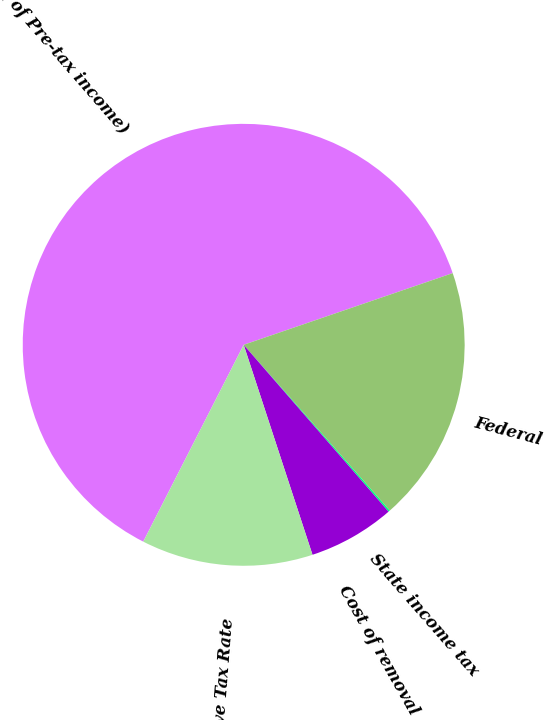Convert chart to OTSL. <chart><loc_0><loc_0><loc_500><loc_500><pie_chart><fcel>( of Pre-tax income)<fcel>Federal<fcel>State income tax<fcel>Cost of removal<fcel>Effective Tax Rate<nl><fcel>62.24%<fcel>18.76%<fcel>0.12%<fcel>6.34%<fcel>12.55%<nl></chart> 